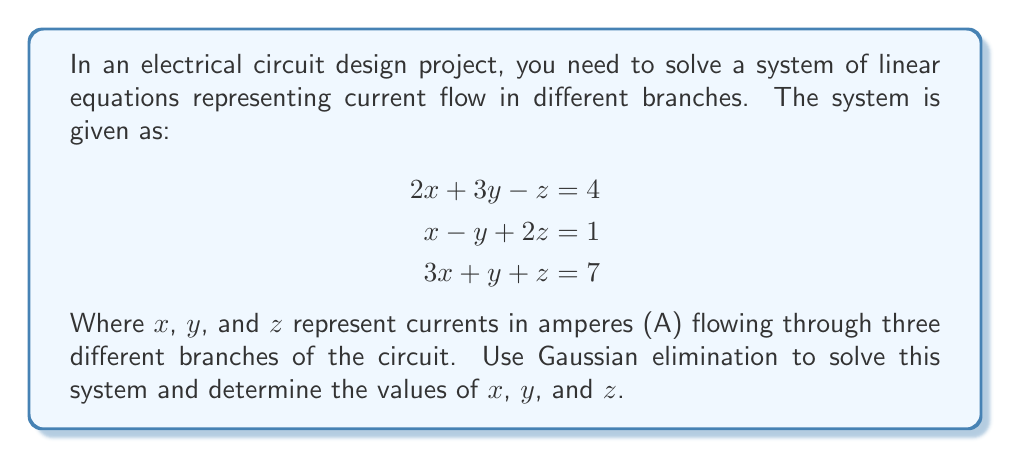Teach me how to tackle this problem. To solve this system using Gaussian elimination, we'll follow these steps:

1) First, we'll write the augmented matrix:

   $$\begin{bmatrix}
   2 & 3 & -1 & 4 \\
   1 & -1 & 2 & 1 \\
   3 & 1 & 1 & 7
   \end{bmatrix}$$

2) We'll use the first row as our pivot row. Subtract 1/2 of the first row from the second row:

   $$\begin{bmatrix}
   2 & 3 & -1 & 4 \\
   0 & -2.5 & 2.5 & -1 \\
   3 & 1 & 1 & 7
   \end{bmatrix}$$

3) Now subtract 3/2 of the first row from the third row:

   $$\begin{bmatrix}
   2 & 3 & -1 & 4 \\
   0 & -2.5 & 2.5 & -1 \\
   0 & -3.5 & 2.5 & 1
   \end{bmatrix}$$

4) Use the second row as the new pivot row. Add 1.4 times the second row to the third row:

   $$\begin{bmatrix}
   2 & 3 & -1 & 4 \\
   0 & -2.5 & 2.5 & -1 \\
   0 & 0 & 6 & 0.4
   \end{bmatrix}$$

5) Now we have an upper triangular matrix. We can solve for z:

   $6z = 0.4$
   $z = \frac{0.4}{6} = \frac{1}{15} \approx 0.0667$ A

6) Substitute this value of z back into the second row:

   $-2.5y + 2.5(\frac{1}{15}) = -1$
   $-2.5y = -1 - \frac{1}{6}$
   $y = \frac{7}{15} \approx 0.4667$ A

7) Finally, substitute the values of y and z into the first row:

   $2x + 3(\frac{7}{15}) - \frac{1}{15} = 4$
   $2x = 4 - \frac{21}{15} + \frac{1}{15} = \frac{40}{15}$
   $x = \frac{20}{15} = \frac{4}{3} \approx 1.3333$ A

Thus, we have solved for x, y, and z using Gaussian elimination.
Answer: $x = \frac{4}{3} \approx 1.3333$ A
$y = \frac{7}{15} \approx 0.4667$ A
$z = \frac{1}{15} \approx 0.0667$ A 